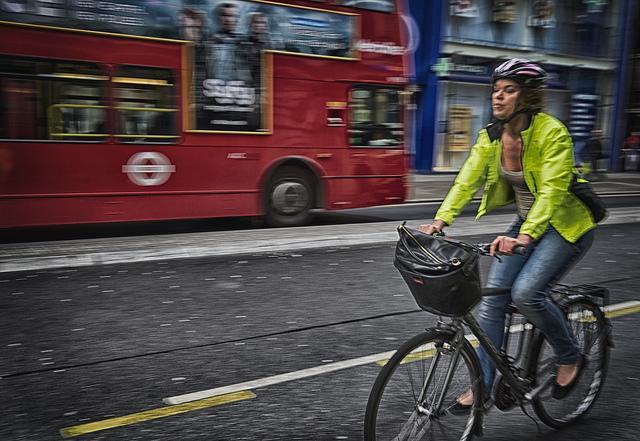Does the women have a helmet on?
Answer briefly. Yes. What is in her ears?
Answer briefly. Headphones. Is the woman wearing pants?
Give a very brief answer. Yes. What fabric is the woman's jeans made of?
Concise answer only. Denim. Does her bike match her outfit?
Concise answer only. Yes. What color is her jacket?
Give a very brief answer. Green. Is she riding down a two-way street?
Quick response, please. Yes. What does the bus say on top of it?
Be succinct. Syfy. 